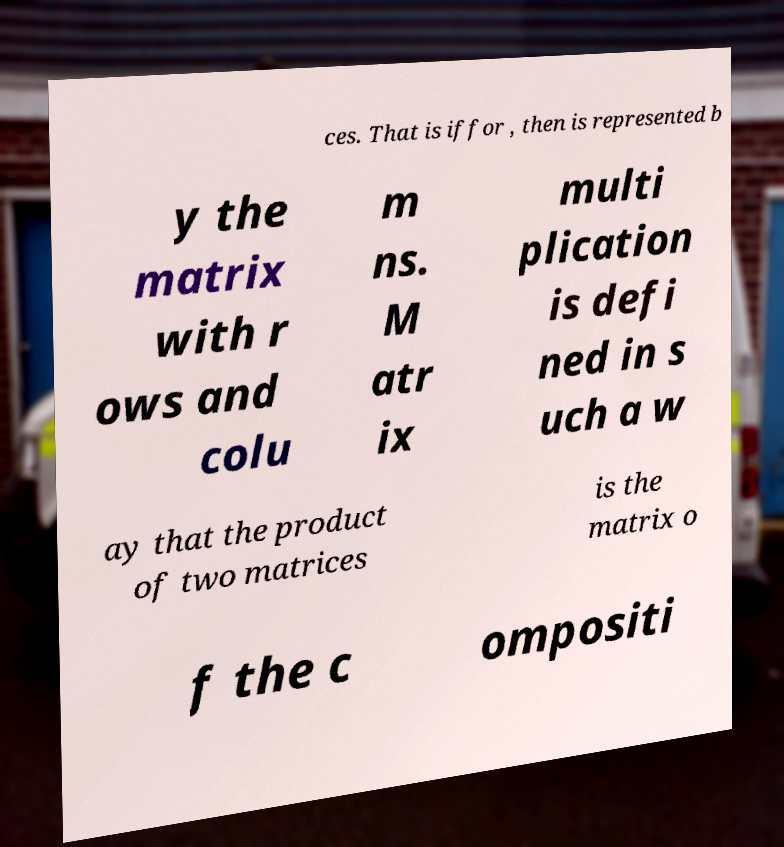Could you extract and type out the text from this image? ces. That is iffor , then is represented b y the matrix with r ows and colu m ns. M atr ix multi plication is defi ned in s uch a w ay that the product of two matrices is the matrix o f the c ompositi 